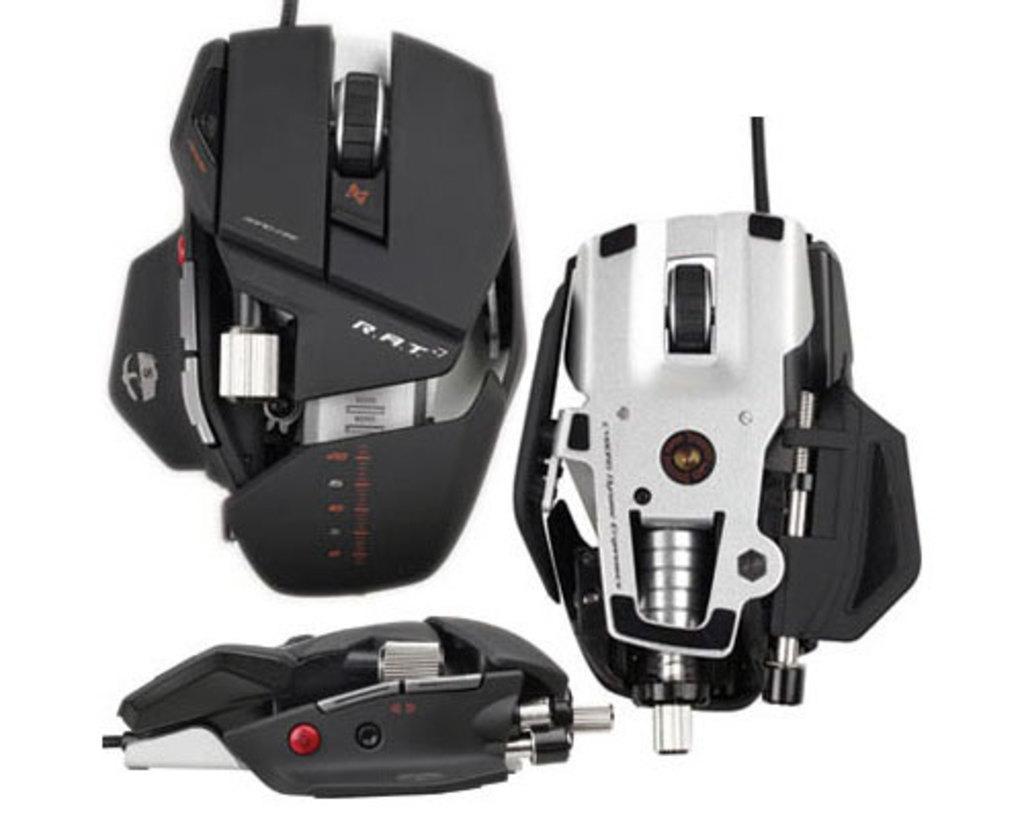Describe this image in one or two sentences. In this image we can see gaming mouses. 